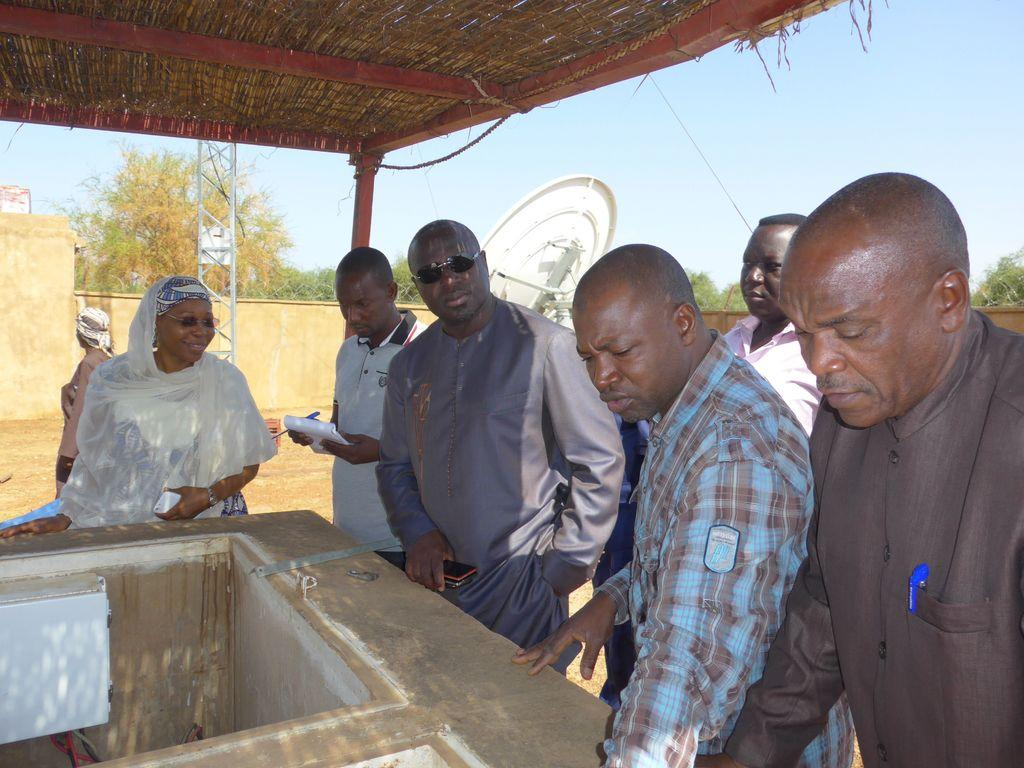What are the people in the image doing? The people in the image are standing under a shed. What can be seen in the bottom left of the image? There is a cement tank in the bottom left of the image. What objects can be seen in the background of the image? There is a dish and a wall in the background of the image. What type of vegetation is visible in the background of the image? There are trees in the background of the image. What is visible in the sky in the background of the image? The sky is visible in the background of the image. What type of jam is being offered by the boy in the image? There is no boy present in the image, and therefore no jam is being offered. 